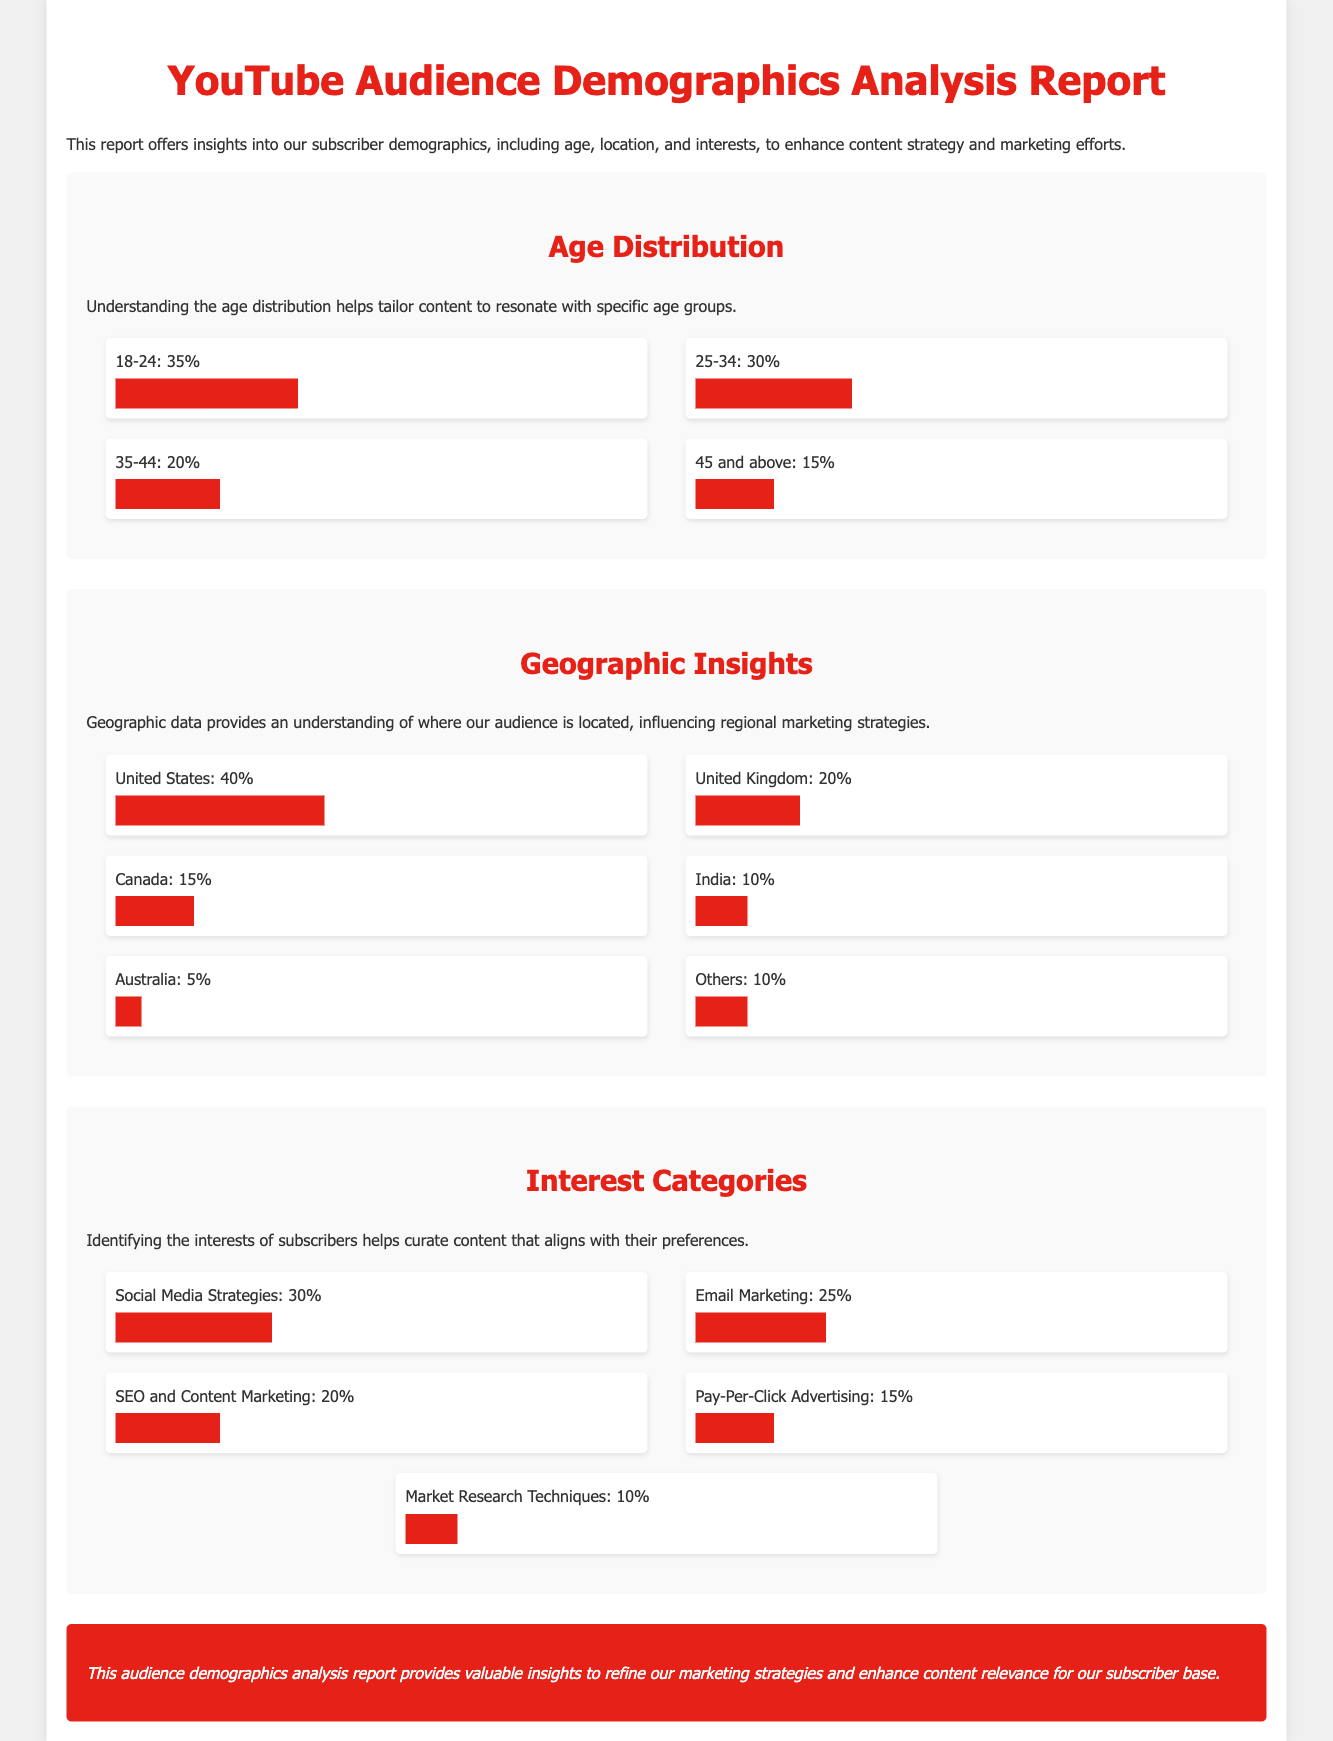What is the largest age group of subscribers? The age distribution shows that the largest age group is 18-24, which comprises 35% of the audience.
Answer: 18-24 What percentage of subscribers are aged 45 and above? According to the age distribution chart, the percentage of subscribers aged 45 and above is 15%.
Answer: 15% Which country has the highest percentage of subscribers? The geographic insights indicate that the United States has the highest percentage of subscribers at 40%.
Answer: United States What is the percentage of subscribers interested in Social Media Strategies? The interest categories reveal that 30% of subscribers are interested in Social Media Strategies.
Answer: 30% Total percentage of subscribers from Canada and Australia? The total percentage from Canada (15%) and Australia (5%) is calculated as 15% + 5% = 20%.
Answer: 20% What is the main interest category among subscribers? The interest categories data shows that Social Media Strategies is the main interest category at 30%.
Answer: Social Media Strategies How many interest categories are listed in the report? The report lists a total of five interest categories under Interest Categories.
Answer: Five What is the conclusion of the demographics analysis report? The conclusion states that the report provides insights to refine marketing strategies and enhance content relevance.
Answer: Refine marketing strategies What percentage of subscribers are located in the United Kingdom? The geographic insights chart indicates that 20% of subscribers are located in the United Kingdom.
Answer: 20% 